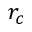<formula> <loc_0><loc_0><loc_500><loc_500>r _ { c }</formula> 